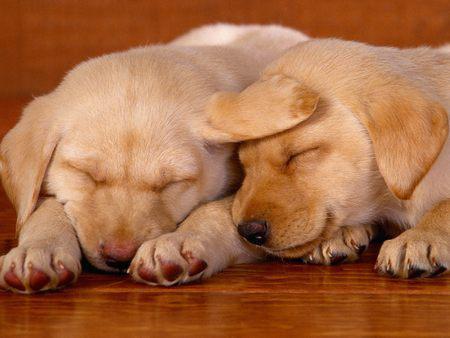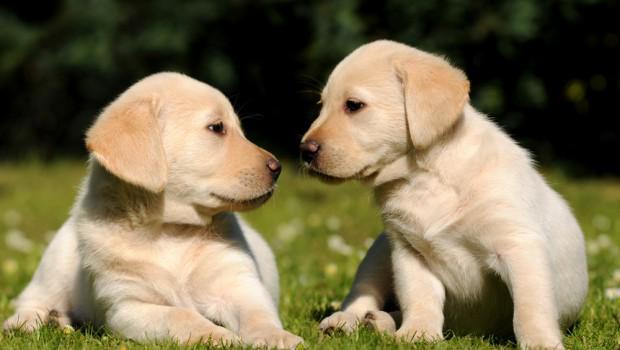The first image is the image on the left, the second image is the image on the right. Given the left and right images, does the statement "One image shows side-by-side puppies posed with front paws dangling over an edge, and the other image shows one blond pup in position to lick the blond pup next to it." hold true? Answer yes or no. No. The first image is the image on the left, the second image is the image on the right. For the images shown, is this caption "The two dogs in one of the images are sitting in a container." true? Answer yes or no. No. 